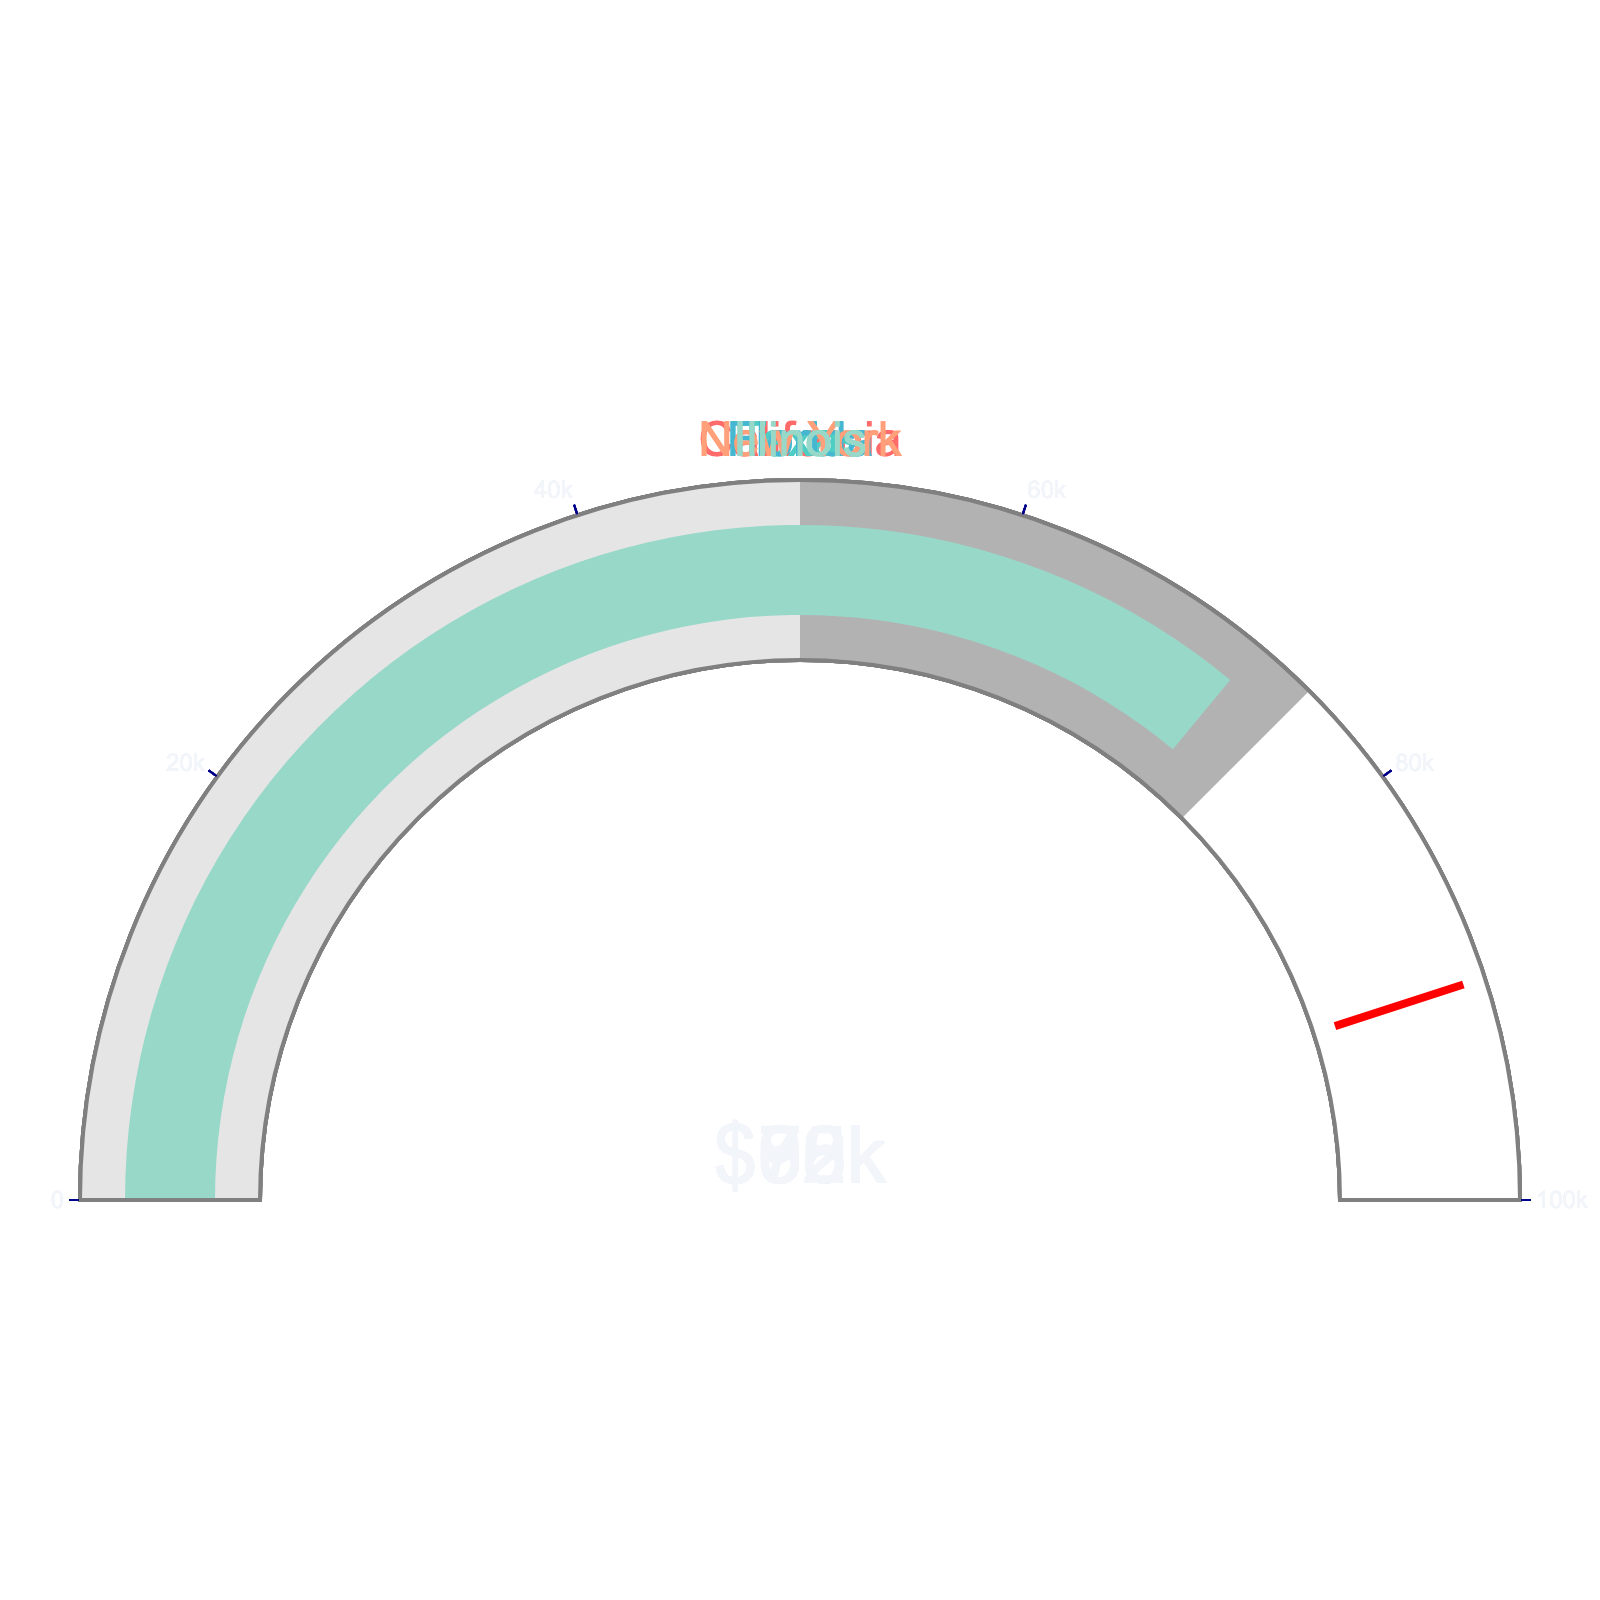What is the average settlement amount for loss of consciousness defense cases in California? The gauge chart shows the settlement amount for California cases. It indicates $75,000.
Answer: $75,000 How much higher is the settlement amount in Florida compared to Texas? The settlement amount for Florida is $82,000, while for Texas it is $68,000. The difference is $82,000 - $68,000 = $14,000.
Answer: $14,000 Which state has the highest settlement amount and what is that amount? The gauge chart indicates that New York has the highest settlement amount, which is $90,000.
Answer: New York, $90,000 Between Illinois and California, which state has a lower settlement amount and what is that amount? The settlement amount for Illinois is $72,000 while for California it is $75,000. Illinois has the lower amount, which is $72,000.
Answer: Illinois, $72,000 What is the median settlement amount among the states listed? The settlement amounts are $68,000, $72,000, $75,000, $82,000, and $90,000. The median is the middle value, which is $75,000.
Answer: $75,000 What is the range of settlement amounts across the states? The maximum settlement amount is $90,000 (New York) and the minimum is $68,000 (Texas). The range is $90,000 - $68,000 = $22,000.
Answer: $22,000 Are there any states with settlement amounts above $80,000? If so, which ones? The gauge chart displays that Florida and New York have settlement amounts above $80,000 ($82,000 and $90,000 respectively).
Answer: Florida, New York What is the combined settlement amount for Texas and Illinois? The settlement amounts for Texas and Illinois are $68,000 and $72,000 respectively. Combined, they are $68,000 + $72,000 = $140,000.
Answer: $140,000 Within the range of $70,000 to $80,000, how many states' settlement amounts fall? The settlement amounts for Illinois ($72,000) and California ($75,000) fall within the $70,000 to $80,000 range.
Answer: 2 What is the average of the highest and lowest settlement amounts? The highest settlement amount is $90,000 (New York) and the lowest is $68,000 (Texas). Their average is ($90,000 + $68,000) / 2 = $79,000.
Answer: $79,000 